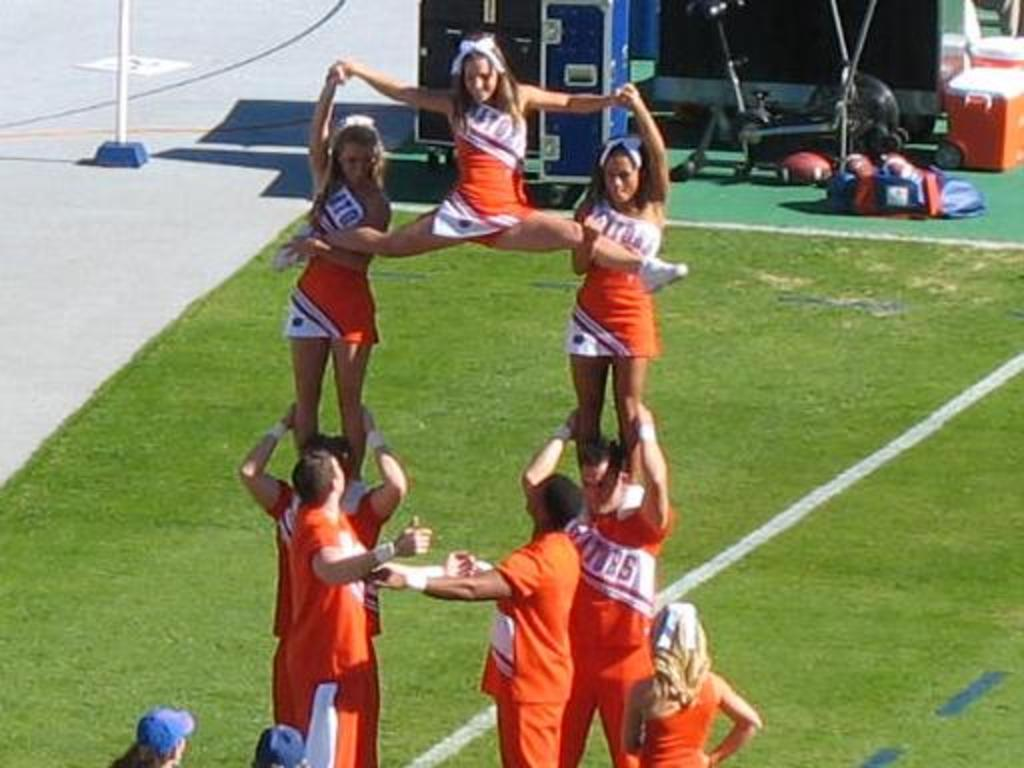What type of clothing accessory can be seen in the image? There are caps visible in the image. Where are the people in the image located? The people are on the grass in the image. What can be seen in the background of the image? There are boxes, a pole, and objects on the ground in the background of the image. Reasoning: Let' Let's think step by step in order to produce the conversation. We start by identifying the main subject in the image, which is the caps. Then, we expand the conversation to include the people and their location on the grass. Finally, we describe the background of the image, including the boxes, pole, and objects on the ground. Each question is designed to elicit a specific detail about the image that is known from the provided facts. Absurd Question/Answer: Can you see any squirrels playing with balls in the image? There are no squirrels or balls present in the image. Is there a plane visible in the sky in the image? The image does not show a plane or any sky, so it cannot be determined if there is a plane visible. 